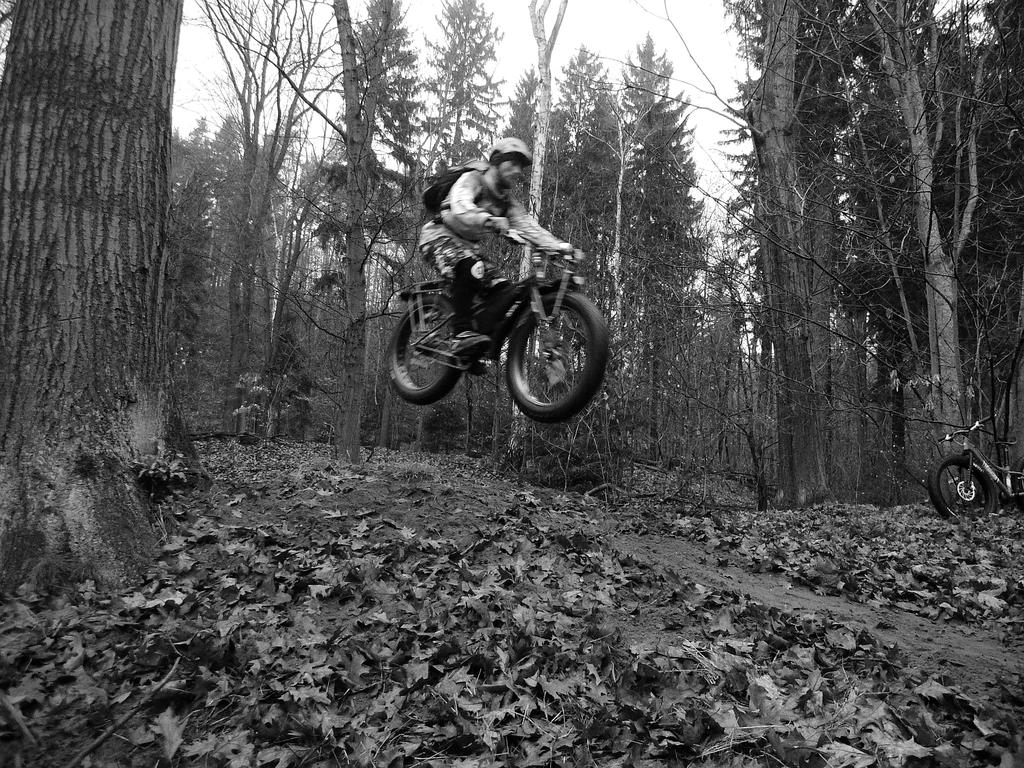What is the color scheme of the image? The image is black and white. What is the person in the image doing? The person is riding a motorbike. What is the person wearing on their back? The person is wearing a bag. What safety gear is the person wearing? The person is wearing a helmet. What type of vegetation can be seen in the image? There are trees visible in the image. Can you tell me how many yaks are grazing near the trees in the image? There are no yaks present in the image; it only features a person riding a motorbike and trees in the background. 